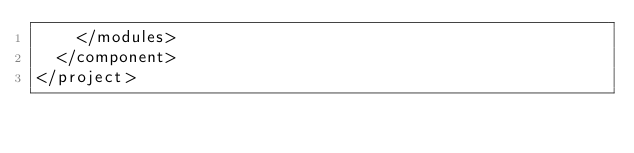Convert code to text. <code><loc_0><loc_0><loc_500><loc_500><_XML_>    </modules>
  </component>
</project></code> 